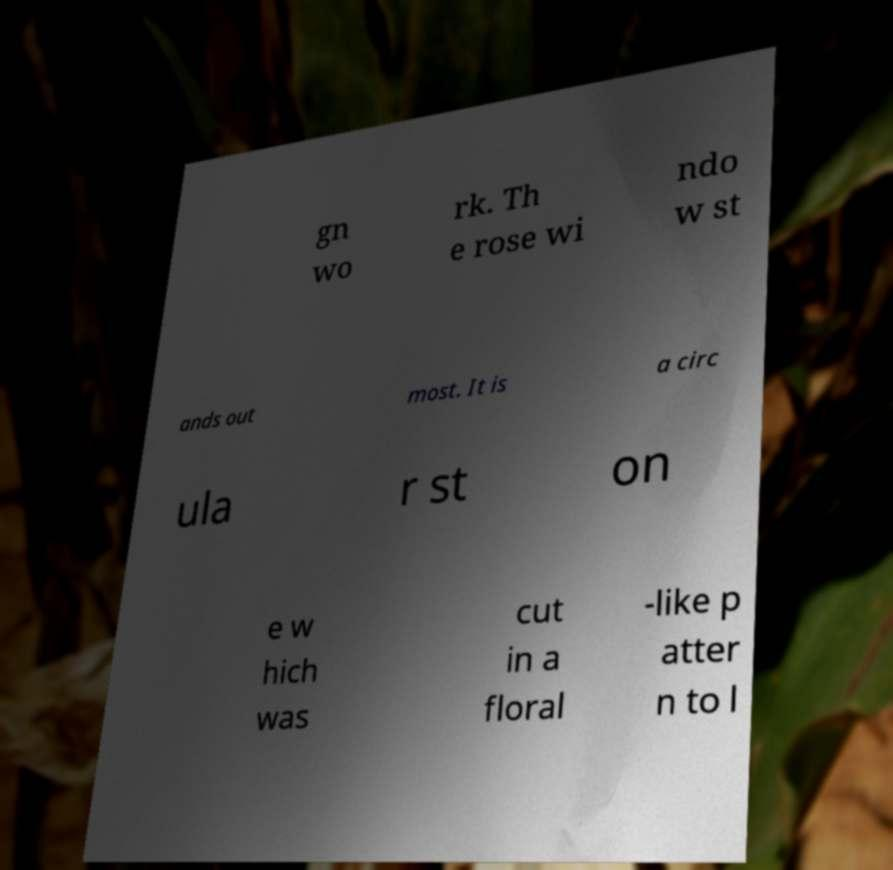Please identify and transcribe the text found in this image. gn wo rk. Th e rose wi ndo w st ands out most. It is a circ ula r st on e w hich was cut in a floral -like p atter n to l 